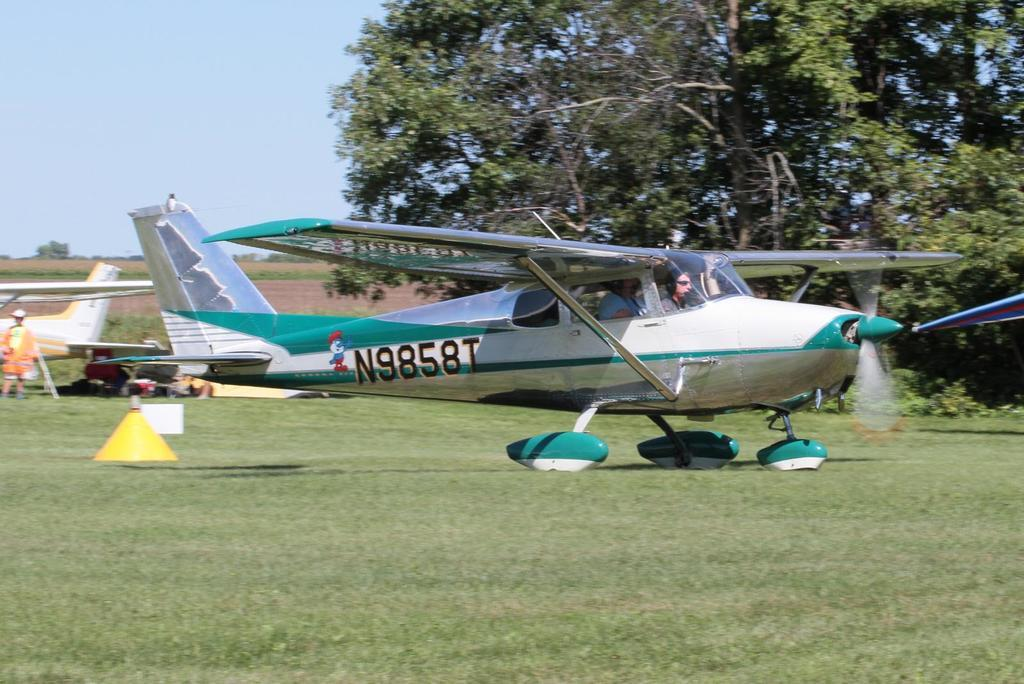Provide a one-sentence caption for the provided image. A N9858T air plane standing on a grassy filed with the pilot sitting at the controls. 